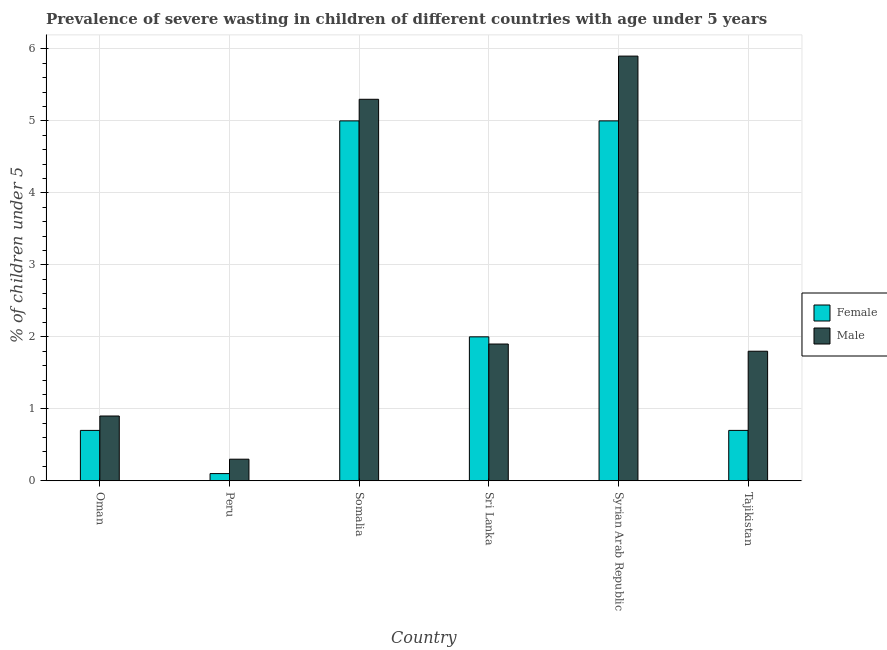How many different coloured bars are there?
Your answer should be compact. 2. How many groups of bars are there?
Your response must be concise. 6. Are the number of bars on each tick of the X-axis equal?
Make the answer very short. Yes. How many bars are there on the 2nd tick from the left?
Keep it short and to the point. 2. How many bars are there on the 2nd tick from the right?
Offer a terse response. 2. What is the label of the 4th group of bars from the left?
Your answer should be compact. Sri Lanka. Across all countries, what is the maximum percentage of undernourished female children?
Keep it short and to the point. 5. Across all countries, what is the minimum percentage of undernourished female children?
Ensure brevity in your answer.  0.1. In which country was the percentage of undernourished male children maximum?
Give a very brief answer. Syrian Arab Republic. What is the total percentage of undernourished male children in the graph?
Offer a terse response. 16.1. What is the difference between the percentage of undernourished male children in Oman and that in Syrian Arab Republic?
Your answer should be compact. -5. What is the difference between the percentage of undernourished male children in Syrian Arab Republic and the percentage of undernourished female children in Sri Lanka?
Offer a terse response. 3.9. What is the average percentage of undernourished female children per country?
Give a very brief answer. 2.25. What is the difference between the percentage of undernourished male children and percentage of undernourished female children in Tajikistan?
Your answer should be compact. 1.1. In how many countries, is the percentage of undernourished male children greater than 3 %?
Give a very brief answer. 2. Is the percentage of undernourished male children in Peru less than that in Syrian Arab Republic?
Keep it short and to the point. Yes. What is the difference between the highest and the second highest percentage of undernourished female children?
Offer a very short reply. 0. What is the difference between the highest and the lowest percentage of undernourished male children?
Keep it short and to the point. 5.6. Is the sum of the percentage of undernourished male children in Oman and Syrian Arab Republic greater than the maximum percentage of undernourished female children across all countries?
Provide a succinct answer. Yes. What does the 1st bar from the left in Sri Lanka represents?
Make the answer very short. Female. What does the 2nd bar from the right in Peru represents?
Provide a short and direct response. Female. How many countries are there in the graph?
Ensure brevity in your answer.  6. Are the values on the major ticks of Y-axis written in scientific E-notation?
Make the answer very short. No. Does the graph contain grids?
Your response must be concise. Yes. Where does the legend appear in the graph?
Keep it short and to the point. Center right. What is the title of the graph?
Your answer should be very brief. Prevalence of severe wasting in children of different countries with age under 5 years. What is the label or title of the Y-axis?
Your response must be concise.  % of children under 5. What is the  % of children under 5 of Female in Oman?
Offer a terse response. 0.7. What is the  % of children under 5 in Male in Oman?
Ensure brevity in your answer.  0.9. What is the  % of children under 5 of Female in Peru?
Your answer should be very brief. 0.1. What is the  % of children under 5 of Male in Peru?
Your answer should be compact. 0.3. What is the  % of children under 5 in Female in Somalia?
Offer a terse response. 5. What is the  % of children under 5 of Male in Somalia?
Provide a short and direct response. 5.3. What is the  % of children under 5 of Male in Sri Lanka?
Ensure brevity in your answer.  1.9. What is the  % of children under 5 of Female in Syrian Arab Republic?
Make the answer very short. 5. What is the  % of children under 5 in Male in Syrian Arab Republic?
Keep it short and to the point. 5.9. What is the  % of children under 5 in Female in Tajikistan?
Keep it short and to the point. 0.7. What is the  % of children under 5 of Male in Tajikistan?
Provide a short and direct response. 1.8. Across all countries, what is the maximum  % of children under 5 in Male?
Your answer should be very brief. 5.9. Across all countries, what is the minimum  % of children under 5 of Female?
Your answer should be compact. 0.1. Across all countries, what is the minimum  % of children under 5 in Male?
Offer a very short reply. 0.3. What is the difference between the  % of children under 5 in Male in Oman and that in Somalia?
Keep it short and to the point. -4.4. What is the difference between the  % of children under 5 in Female in Oman and that in Sri Lanka?
Offer a terse response. -1.3. What is the difference between the  % of children under 5 in Female in Oman and that in Syrian Arab Republic?
Your response must be concise. -4.3. What is the difference between the  % of children under 5 in Male in Oman and that in Tajikistan?
Make the answer very short. -0.9. What is the difference between the  % of children under 5 in Male in Peru and that in Sri Lanka?
Offer a terse response. -1.6. What is the difference between the  % of children under 5 of Female in Peru and that in Syrian Arab Republic?
Provide a succinct answer. -4.9. What is the difference between the  % of children under 5 of Male in Peru and that in Syrian Arab Republic?
Provide a succinct answer. -5.6. What is the difference between the  % of children under 5 in Male in Peru and that in Tajikistan?
Provide a succinct answer. -1.5. What is the difference between the  % of children under 5 in Female in Somalia and that in Sri Lanka?
Offer a very short reply. 3. What is the difference between the  % of children under 5 of Male in Somalia and that in Sri Lanka?
Ensure brevity in your answer.  3.4. What is the difference between the  % of children under 5 of Male in Somalia and that in Syrian Arab Republic?
Your answer should be very brief. -0.6. What is the difference between the  % of children under 5 of Female in Somalia and that in Tajikistan?
Provide a succinct answer. 4.3. What is the difference between the  % of children under 5 of Male in Somalia and that in Tajikistan?
Provide a succinct answer. 3.5. What is the difference between the  % of children under 5 of Female in Sri Lanka and that in Syrian Arab Republic?
Your answer should be very brief. -3. What is the difference between the  % of children under 5 of Female in Sri Lanka and that in Tajikistan?
Provide a succinct answer. 1.3. What is the difference between the  % of children under 5 of Male in Sri Lanka and that in Tajikistan?
Your response must be concise. 0.1. What is the difference between the  % of children under 5 of Female in Syrian Arab Republic and that in Tajikistan?
Provide a short and direct response. 4.3. What is the difference between the  % of children under 5 of Male in Syrian Arab Republic and that in Tajikistan?
Make the answer very short. 4.1. What is the difference between the  % of children under 5 in Female in Peru and the  % of children under 5 in Male in Somalia?
Your answer should be compact. -5.2. What is the difference between the  % of children under 5 in Female in Peru and the  % of children under 5 in Male in Sri Lanka?
Give a very brief answer. -1.8. What is the difference between the  % of children under 5 in Female in Peru and the  % of children under 5 in Male in Tajikistan?
Give a very brief answer. -1.7. What is the difference between the  % of children under 5 of Female in Somalia and the  % of children under 5 of Male in Syrian Arab Republic?
Give a very brief answer. -0.9. What is the difference between the  % of children under 5 of Female in Somalia and the  % of children under 5 of Male in Tajikistan?
Offer a terse response. 3.2. What is the difference between the  % of children under 5 of Female in Sri Lanka and the  % of children under 5 of Male in Syrian Arab Republic?
Ensure brevity in your answer.  -3.9. What is the difference between the  % of children under 5 in Female in Syrian Arab Republic and the  % of children under 5 in Male in Tajikistan?
Offer a very short reply. 3.2. What is the average  % of children under 5 in Female per country?
Your answer should be compact. 2.25. What is the average  % of children under 5 of Male per country?
Your answer should be compact. 2.68. What is the difference between the  % of children under 5 in Female and  % of children under 5 in Male in Oman?
Your answer should be compact. -0.2. What is the ratio of the  % of children under 5 in Female in Oman to that in Peru?
Offer a very short reply. 7. What is the ratio of the  % of children under 5 in Female in Oman to that in Somalia?
Provide a short and direct response. 0.14. What is the ratio of the  % of children under 5 of Male in Oman to that in Somalia?
Your response must be concise. 0.17. What is the ratio of the  % of children under 5 in Male in Oman to that in Sri Lanka?
Provide a succinct answer. 0.47. What is the ratio of the  % of children under 5 in Female in Oman to that in Syrian Arab Republic?
Offer a very short reply. 0.14. What is the ratio of the  % of children under 5 in Male in Oman to that in Syrian Arab Republic?
Provide a short and direct response. 0.15. What is the ratio of the  % of children under 5 of Female in Peru to that in Somalia?
Give a very brief answer. 0.02. What is the ratio of the  % of children under 5 of Male in Peru to that in Somalia?
Provide a succinct answer. 0.06. What is the ratio of the  % of children under 5 of Male in Peru to that in Sri Lanka?
Make the answer very short. 0.16. What is the ratio of the  % of children under 5 in Female in Peru to that in Syrian Arab Republic?
Keep it short and to the point. 0.02. What is the ratio of the  % of children under 5 of Male in Peru to that in Syrian Arab Republic?
Your answer should be very brief. 0.05. What is the ratio of the  % of children under 5 of Female in Peru to that in Tajikistan?
Give a very brief answer. 0.14. What is the ratio of the  % of children under 5 in Male in Somalia to that in Sri Lanka?
Offer a terse response. 2.79. What is the ratio of the  % of children under 5 of Male in Somalia to that in Syrian Arab Republic?
Ensure brevity in your answer.  0.9. What is the ratio of the  % of children under 5 of Female in Somalia to that in Tajikistan?
Your response must be concise. 7.14. What is the ratio of the  % of children under 5 of Male in Somalia to that in Tajikistan?
Keep it short and to the point. 2.94. What is the ratio of the  % of children under 5 of Male in Sri Lanka to that in Syrian Arab Republic?
Keep it short and to the point. 0.32. What is the ratio of the  % of children under 5 of Female in Sri Lanka to that in Tajikistan?
Provide a succinct answer. 2.86. What is the ratio of the  % of children under 5 of Male in Sri Lanka to that in Tajikistan?
Keep it short and to the point. 1.06. What is the ratio of the  % of children under 5 in Female in Syrian Arab Republic to that in Tajikistan?
Keep it short and to the point. 7.14. What is the ratio of the  % of children under 5 of Male in Syrian Arab Republic to that in Tajikistan?
Your answer should be very brief. 3.28. What is the difference between the highest and the second highest  % of children under 5 of Female?
Give a very brief answer. 0. What is the difference between the highest and the lowest  % of children under 5 of Male?
Give a very brief answer. 5.6. 